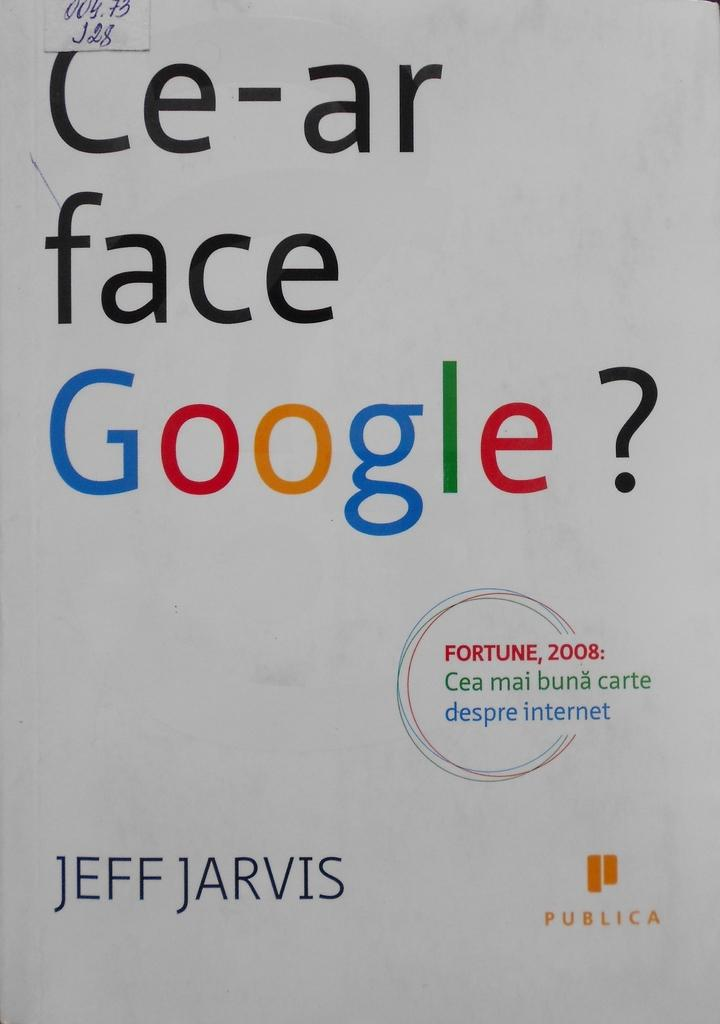<image>
Describe the image concisely. A white poster for Google created by Jeff Jarvis with teh google logo in color. 